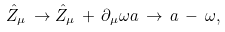<formula> <loc_0><loc_0><loc_500><loc_500>\hat { Z } _ { \mu } \, \rightarrow \hat { Z } _ { \mu } \, + \, \partial _ { \mu } \omega a \, \rightarrow \, a \, - \, \omega ,</formula> 